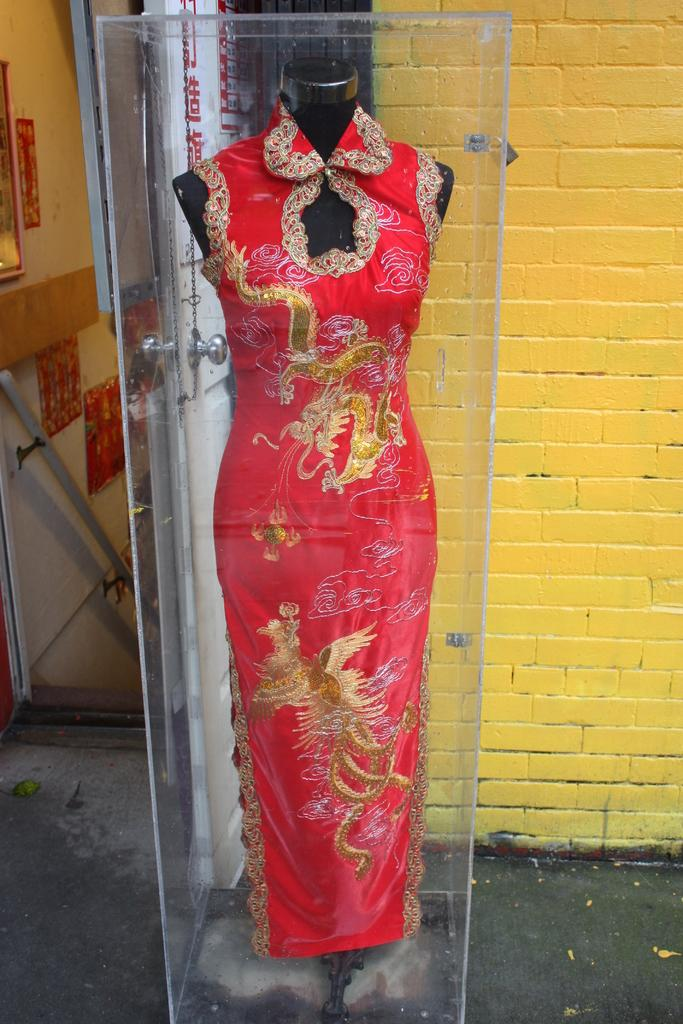What is the woman in the image dressed as? The woman in the image is dressed as a doll. How is the woman displayed in the image? The woman is placed in a glass box. Where is the glass box located in the image? The glass box is on a platform. What can be seen in the background of the image? There is a wall, a pole, a window, and frames on the wall in the background of the image. What type of drum can be seen in the image? There is no drum present in the image. 